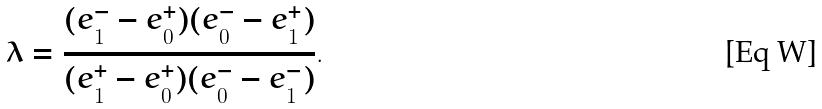<formula> <loc_0><loc_0><loc_500><loc_500>\lambda = \frac { ( e _ { 1 } ^ { - } - e _ { 0 } ^ { + } ) ( e _ { 0 } ^ { - } - e _ { 1 } ^ { + } ) } { ( e _ { 1 } ^ { + } - e _ { 0 } ^ { + } ) ( e _ { 0 } ^ { - } - e _ { 1 } ^ { - } ) } .</formula> 